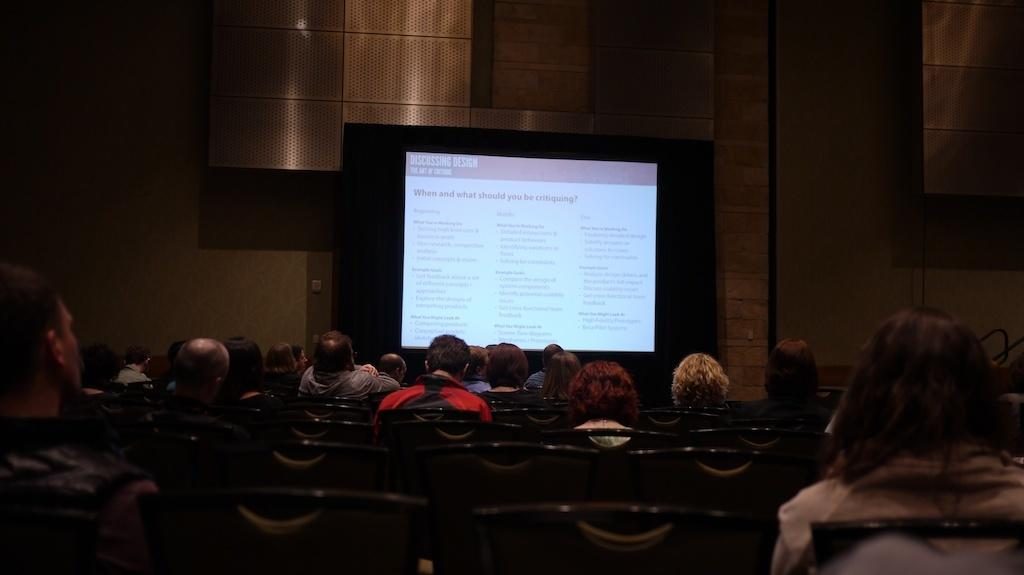What are the people in the image doing? The people in the image are sitting in the center. What can be seen in the background of the image? There is a wall and a screen in the background of the image. What type of engine is visible in the image? There is no engine present in the image. 